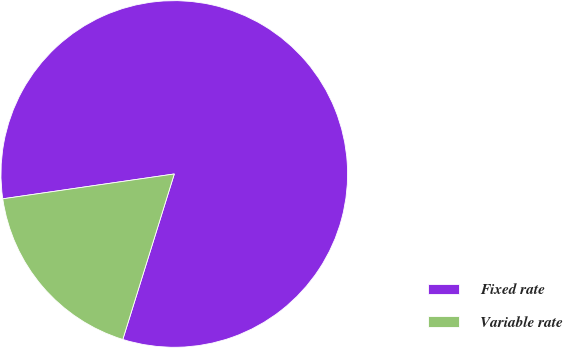Convert chart. <chart><loc_0><loc_0><loc_500><loc_500><pie_chart><fcel>Fixed rate<fcel>Variable rate<nl><fcel>82.09%<fcel>17.91%<nl></chart> 